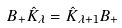<formula> <loc_0><loc_0><loc_500><loc_500>B _ { + } \hat { K } _ { \lambda } = \hat { K } _ { \lambda + 1 } B _ { + }</formula> 